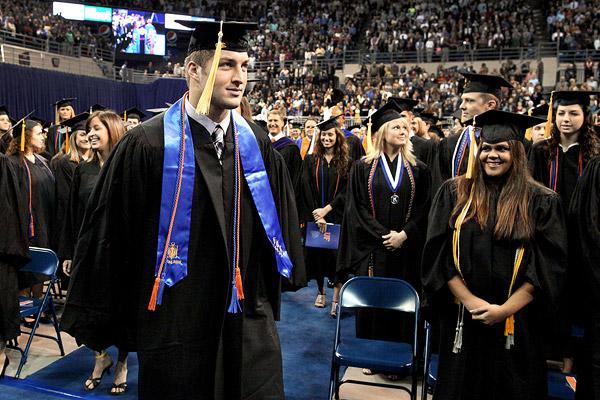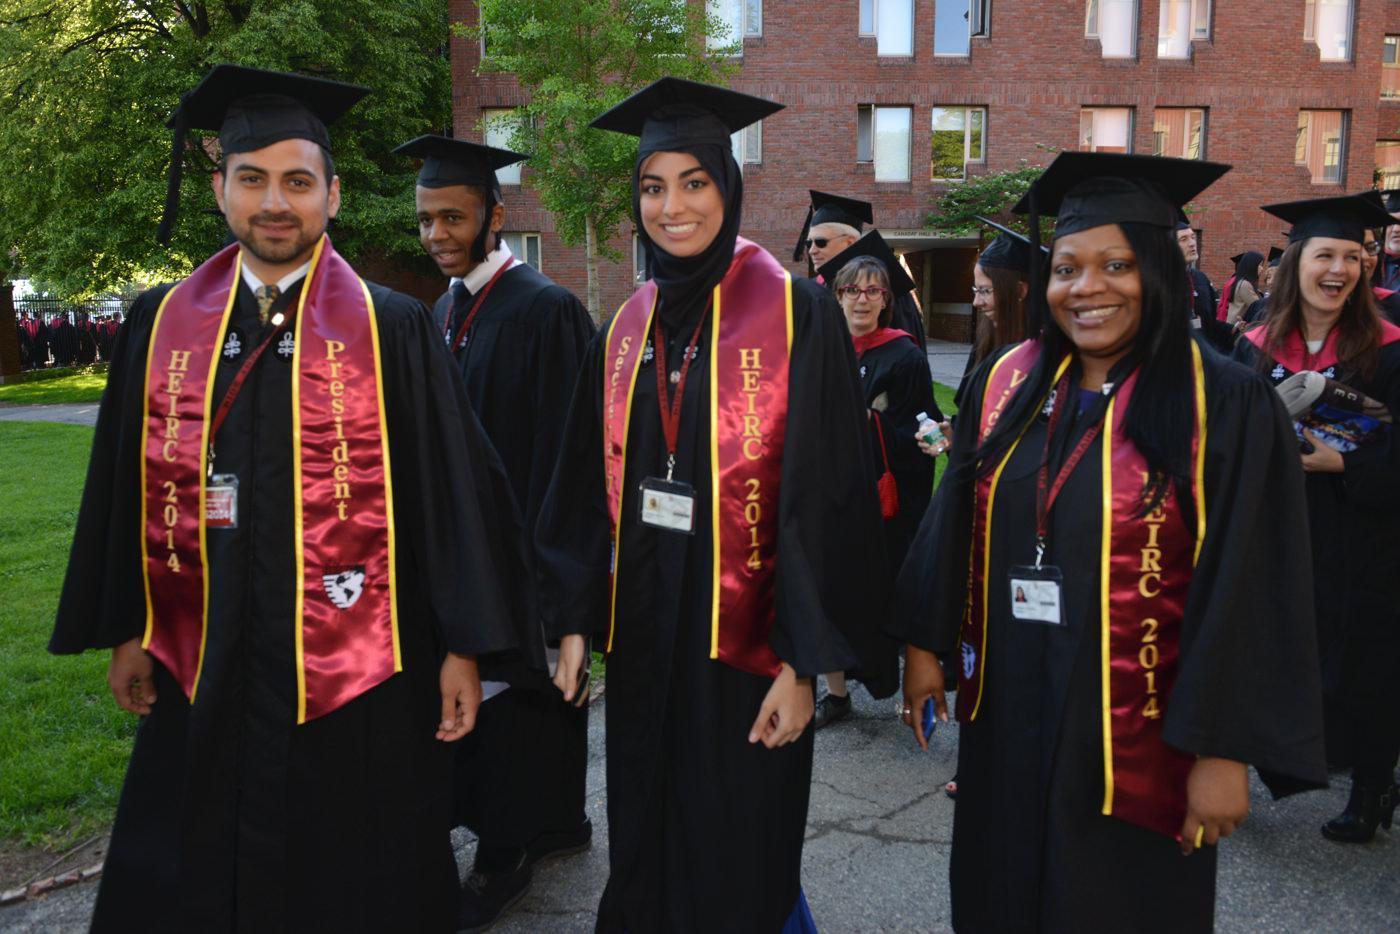The first image is the image on the left, the second image is the image on the right. Evaluate the accuracy of this statement regarding the images: "One image shows a group of graduates posed outdoors wearing different colored robes with three black stripes per sleeve.". Is it true? Answer yes or no. No. The first image is the image on the left, the second image is the image on the right. Analyze the images presented: Is the assertion "The graduates in each picture are posing outside." valid? Answer yes or no. No. 